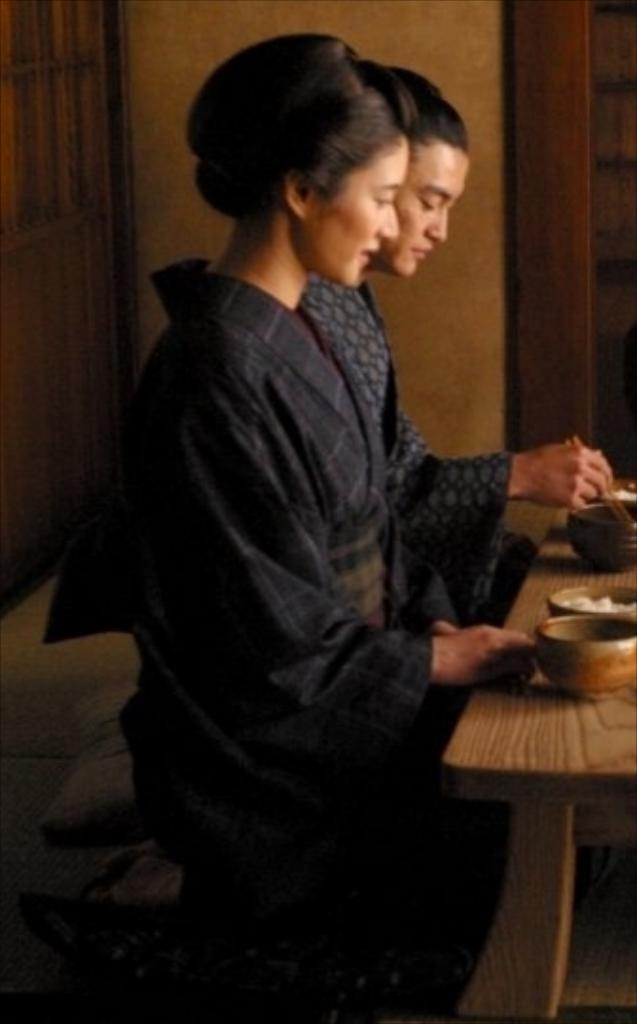Describe this image in one or two sentences. In this Picture we can see that a Chinese woman wearing the black traditional dress sitting on the cushion near the table and eating , Beside a man eating with chop sticks and wearing blue color dress. 